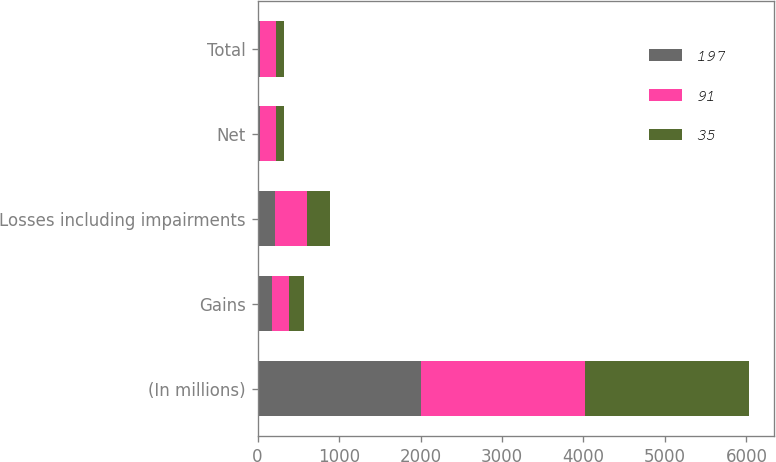<chart> <loc_0><loc_0><loc_500><loc_500><stacked_bar_chart><ecel><fcel>(In millions)<fcel>Gains<fcel>Losses including impairments<fcel>Net<fcel>Total<nl><fcel>197<fcel>2012<fcel>177<fcel>211<fcel>34<fcel>35<nl><fcel>91<fcel>2011<fcel>205<fcel>402<fcel>197<fcel>197<nl><fcel>35<fcel>2010<fcel>190<fcel>281<fcel>91<fcel>91<nl></chart> 